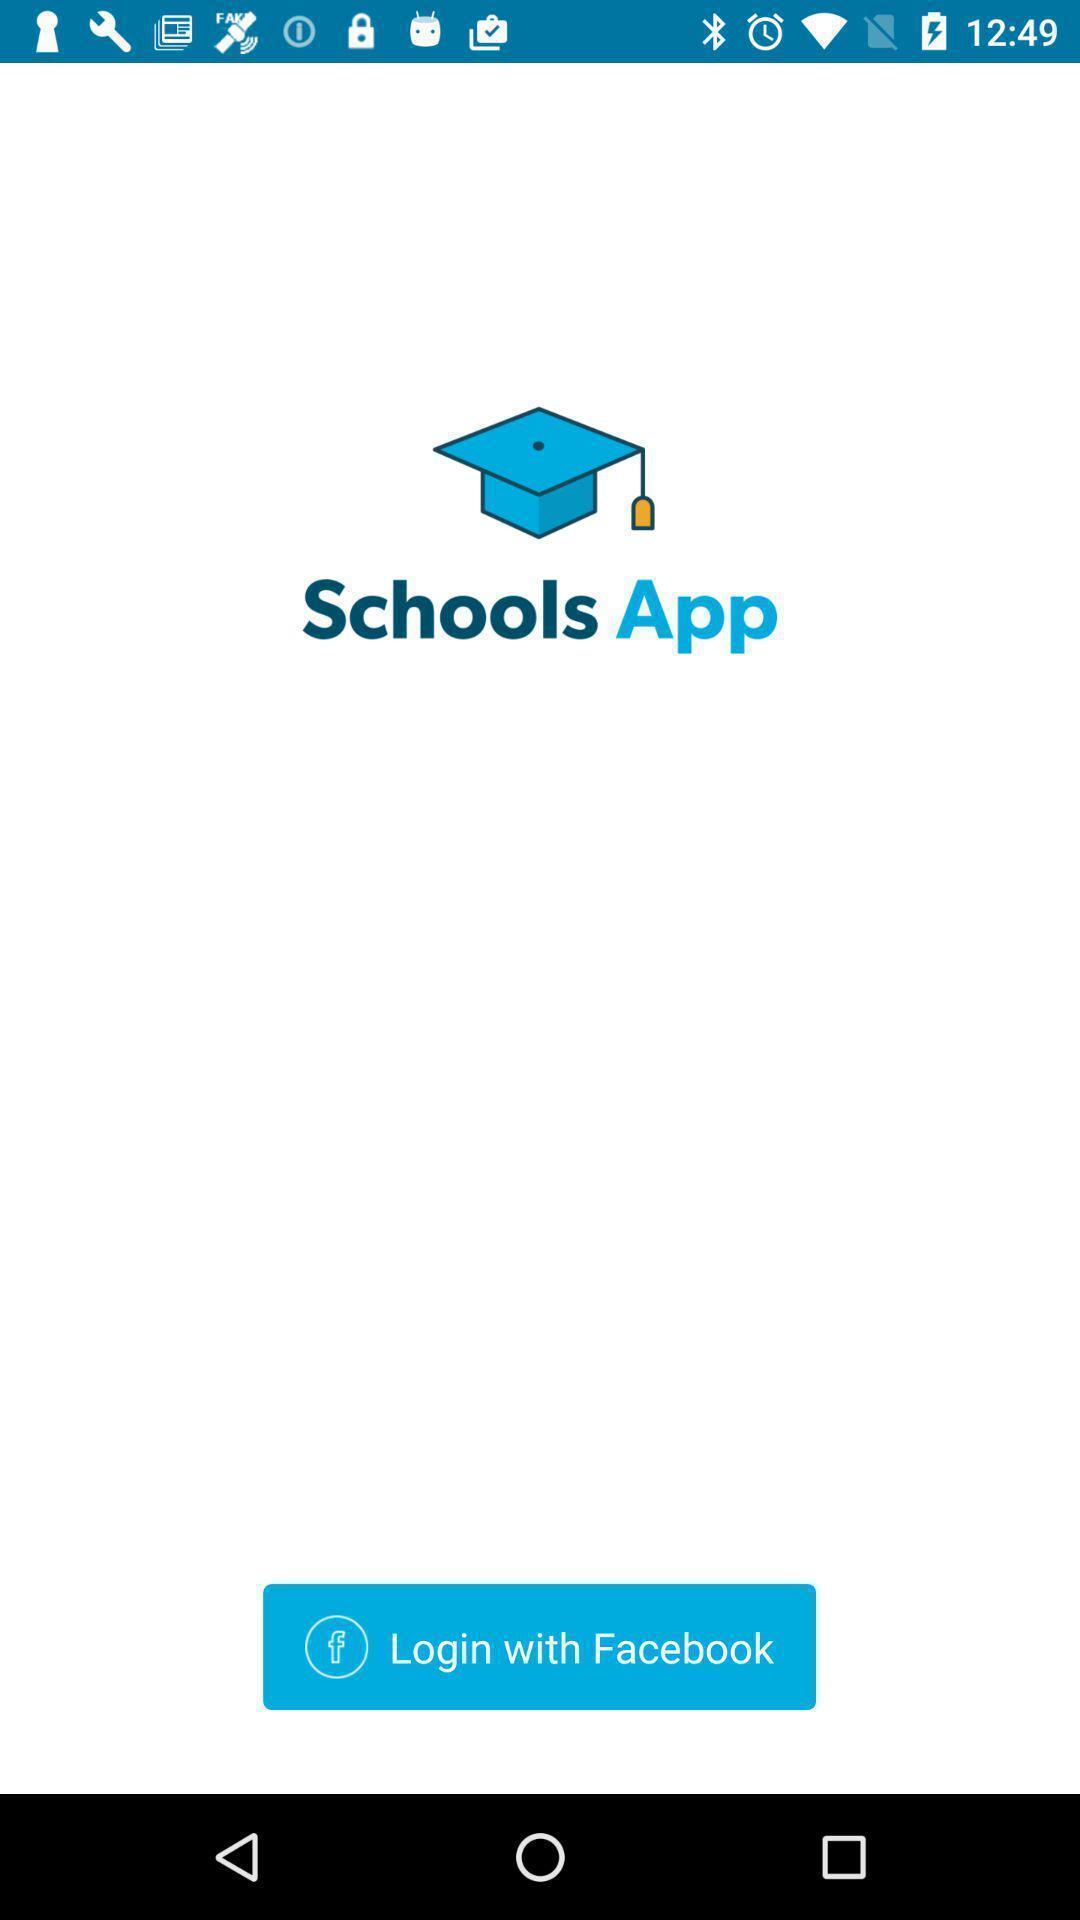Provide a textual representation of this image. Welcome page displaying to login of an education application. 